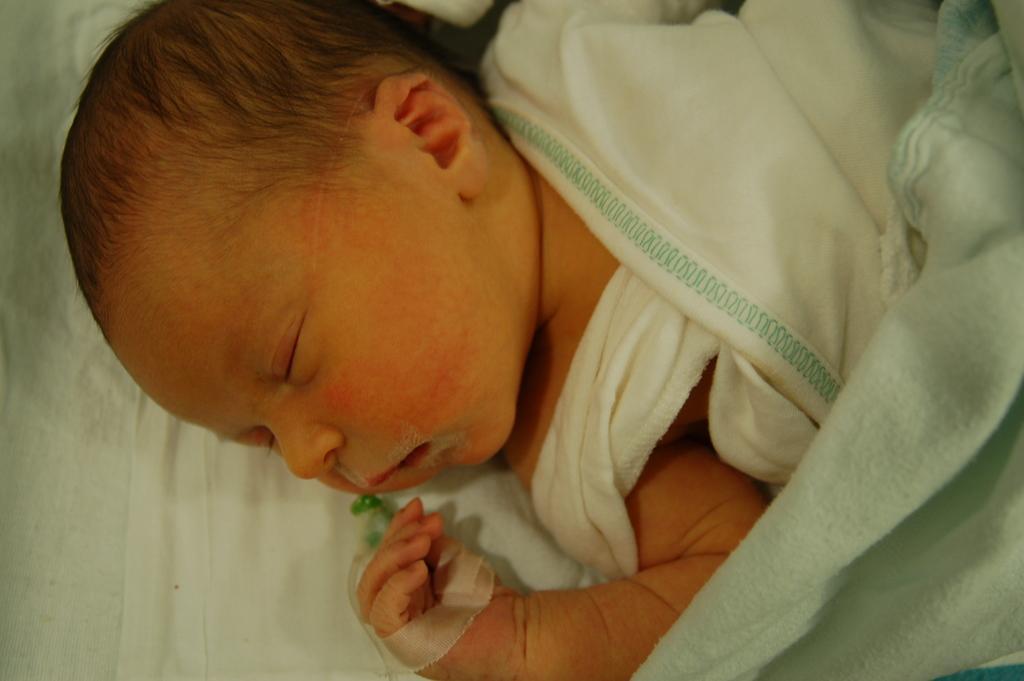In one or two sentences, can you explain what this image depicts? In this image I can see a baby sleeping. I can also see a white color blanket. 